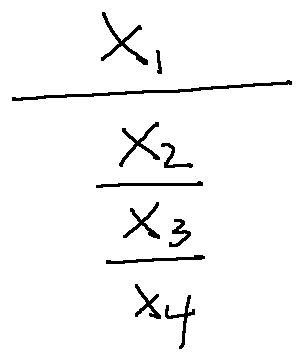Convert formula to latex. <formula><loc_0><loc_0><loc_500><loc_500>\frac { x _ { 1 } } { \frac { x _ { 2 } } { \frac { x _ { 3 } } { x _ { 4 } } } }</formula> 